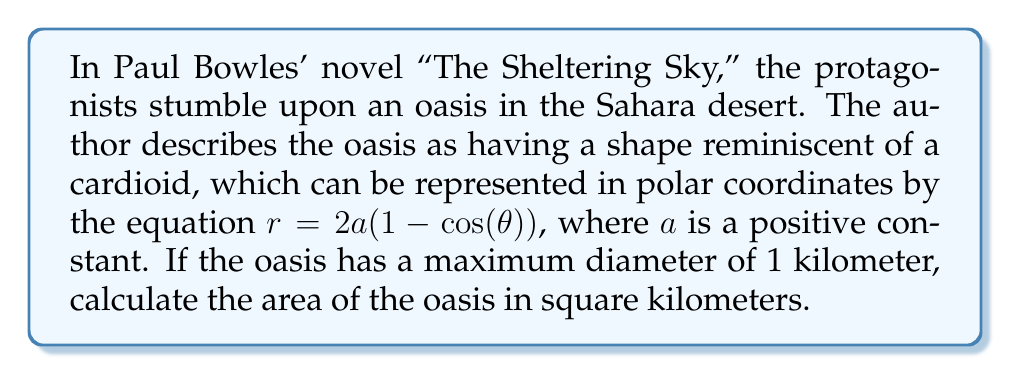What is the answer to this math problem? To solve this problem, we'll follow these steps:

1) First, we need to determine the value of $a$. Given that the maximum diameter is 1 kilometer, we can find $a$:

   The maximum value of $r$ occurs when $\cos(\theta) = -1$, i.e., when $\theta = \pi$:
   
   $r_{max} = 2a(1 - (-1)) = 4a = 0.5$ km (half the diameter)
   
   Therefore, $a = 0.125$ km

2) The area of a region in polar coordinates is given by the formula:

   $$A = \frac{1}{2} \int_{0}^{2\pi} r^2 d\theta$$

3) Substituting our equation for $r$:

   $$A = \frac{1}{2} \int_{0}^{2\pi} [2a(1 - \cos(\theta))]^2 d\theta$$

4) Expanding the squared term:

   $$A = \frac{1}{2} \int_{0}^{2\pi} 4a^2(1 - 2\cos(\theta) + \cos^2(\theta)) d\theta$$

5) Substituting $a = 0.125$:

   $$A = \frac{1}{2} \int_{0}^{2\pi} 4(0.125)^2(1 - 2\cos(\theta) + \cos^2(\theta)) d\theta$$

6) Simplifying:

   $$A = \frac{1}{32} \int_{0}^{2\pi} (1 - 2\cos(\theta) + \cos^2(\theta)) d\theta$$

7) Integrating:

   $$A = \frac{1}{32} [\theta - 2\sin(\theta) + \frac{\theta}{2} + \frac{\sin(2\theta)}{4}]_{0}^{2\pi}$$

8) Evaluating the limits:

   $$A = \frac{1}{32} [2\pi - 0 + \pi + 0] = \frac{3\pi}{32}$$

9) Converting to square kilometers:

   $$A = \frac{3\pi}{32} \approx 0.2945 \text{ km}^2$$
Answer: The area of the oasis is approximately 0.2945 square kilometers. 